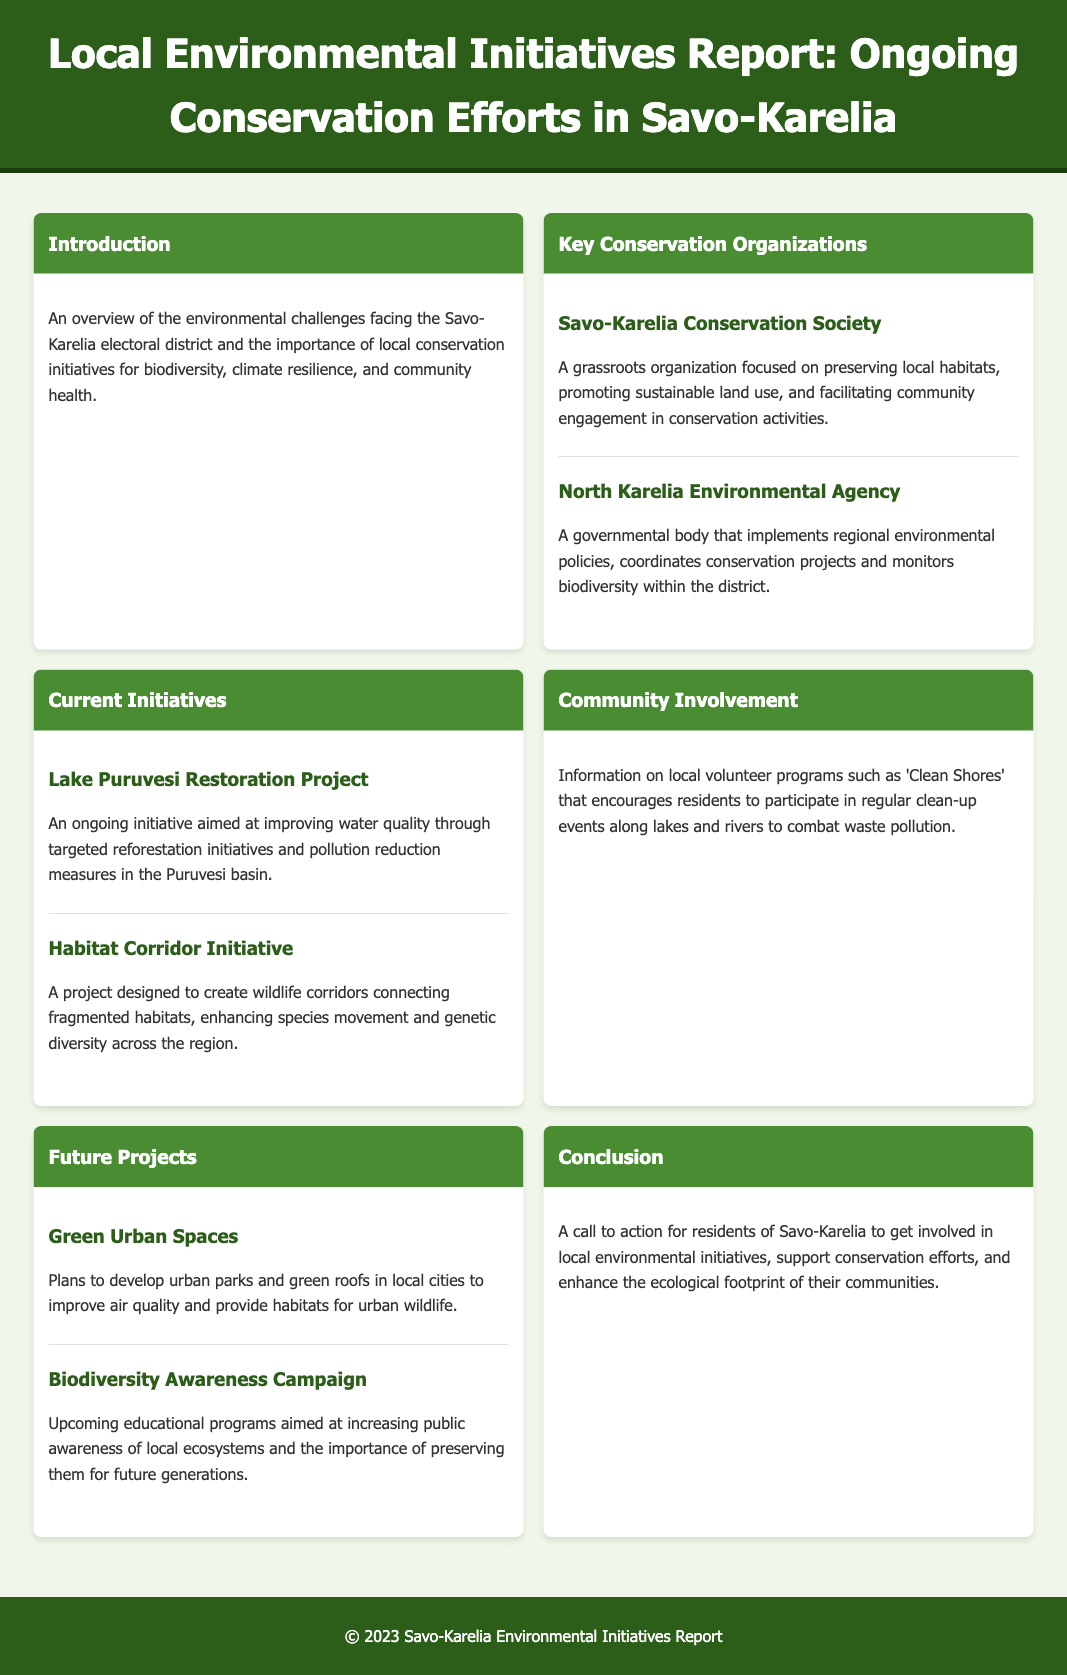What is the focus of the Savo-Karelia Conservation Society? The Savo-Karelia Conservation Society is focused on preserving local habitats, promoting sustainable land use, and facilitating community engagement in conservation activities.
Answer: Preserving local habitats What is the aim of the Lake Puruvesi Restoration Project? The Lake Puruvesi Restoration Project aims at improving water quality through targeted reforestation initiatives and pollution reduction measures in the Puruvesi basin.
Answer: Improving water quality What initiative encourages residents to participate in clean-up events? The 'Clean Shores' initiative encourages residents to participate in regular clean-up events along lakes and rivers.
Answer: Clean Shores What are the future plans for urban development mentioned in the report? Future plans include developing urban parks and green roofs in local cities to improve air quality and provide habitats for urban wildlife.
Answer: Urban parks and green roofs What is the title of the campaign aimed at increasing public awareness of local ecosystems? The title of the campaign aimed at increasing public awareness is the Biodiversity Awareness Campaign.
Answer: Biodiversity Awareness Campaign What type of document is this? This document is a report on local environmental initiatives and ongoing conservation efforts in the Savo-Karelia region.
Answer: Report How many key conservation organizations are mentioned? Two key conservation organizations are mentioned in the document.
Answer: Two 